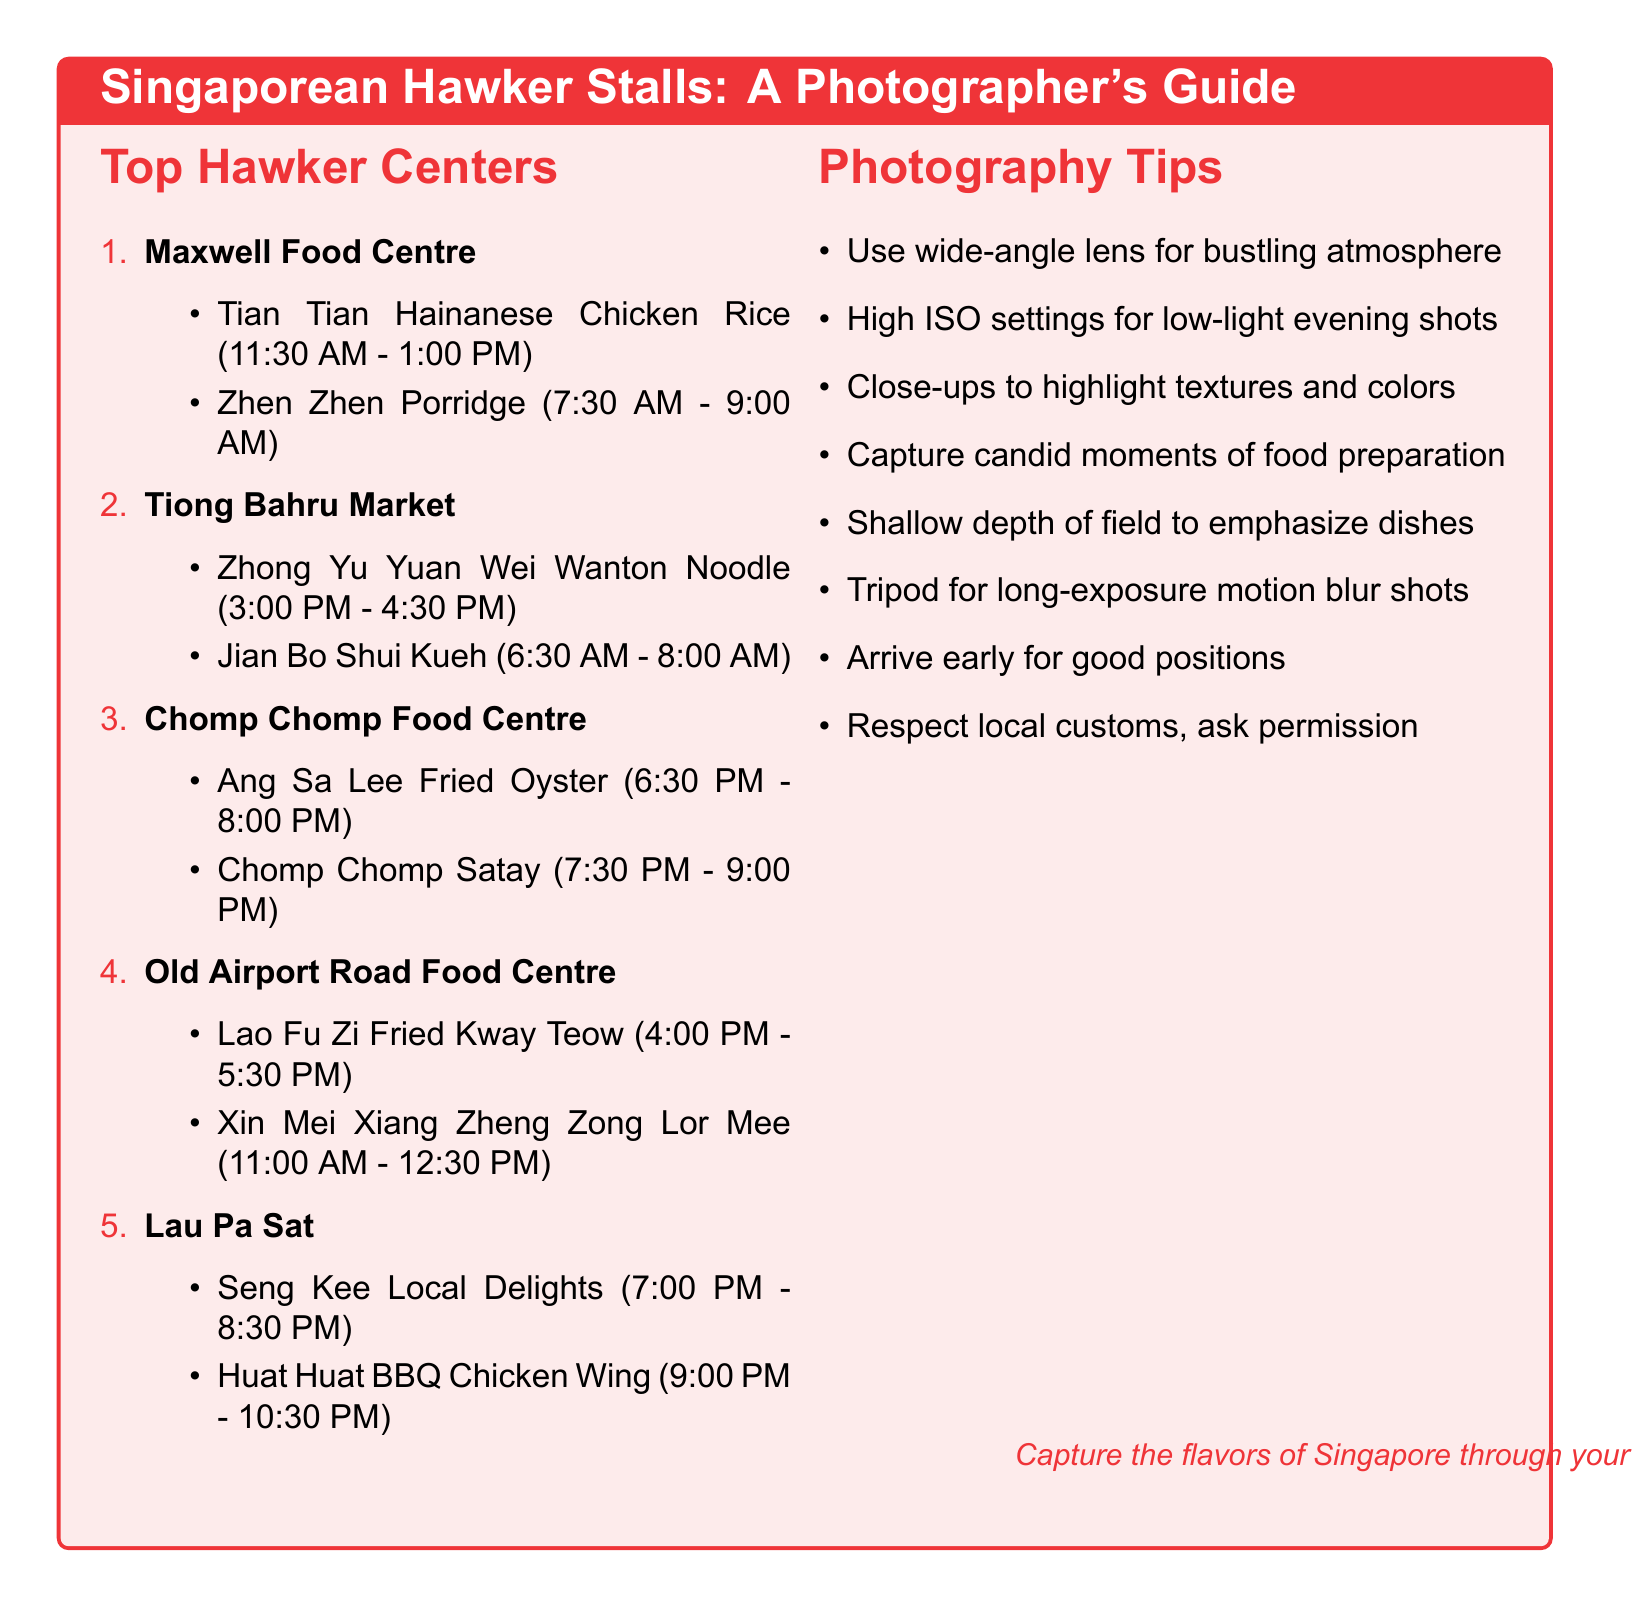What is the location of Maxwell Food Centre? The document lists the address of Maxwell Food Centre as 1 Kadayanallur Street, Singapore 069184.
Answer: 1 Kadayanallur Street, Singapore 069184 What dish is recommended at Tian Tian Hainanese Chicken Rice? The document specifies that the recommended dish at Tian Tian Hainanese Chicken Rice is Hainanese Chicken Rice.
Answer: Hainanese Chicken Rice What is the best time to photograph Zhong Yu Yuan Wei Wanton Noodle? The document states the best time to photograph Zhong Yu Yuan Wei Wanton Noodle as 3:00 PM - 4:30 PM.
Answer: 3:00 PM - 4:30 PM Which stall has dishes available during the evening? The document lists Ang Sa Lee Fried Oyster and Chomp Chomp Satay as stalls with evening dishes.
Answer: Ang Sa Lee Fried Oyster and Chomp Chomp Satay What photography tip suggests using a tripod? The document includes a tip indicating to use a tripod for long-exposure shots to capture motion blur in busy areas.
Answer: Use a tripod for long-exposure shots What time is optimal for photographing Huat Huat BBQ Chicken Wing? The document mentions that the best time to photograph Huat Huat BBQ Chicken Wing is 9:00 PM - 10:30 PM.
Answer: 9:00 PM - 10:30 PM How many notable stalls are listed under Lau Pa Sat? The document states that there are two notable stalls listed under Lau Pa Sat.
Answer: Two What is recommended for capturing candid moments? The document suggests to capture candid moments of hawkers preparing food for authentic scenes.
Answer: Capture candid moments of hawkers preparing food What is the focus of the photography tips section? The photography tips section covers various techniques to enhance food photography in hawker stalls.
Answer: Techniques to enhance food photography 